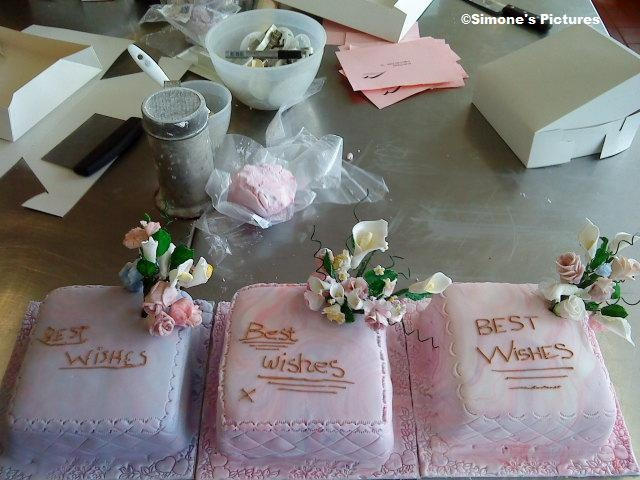Describe the objects in this image and their specific colors. I can see dining table in black, gray, and darkgray tones, cake in black, gray, and darkgray tones, cake in black, darkgray, gray, and lightgray tones, cake in black, darkgray, gray, and lavender tones, and bowl in black, darkgray, lightblue, and gray tones in this image. 